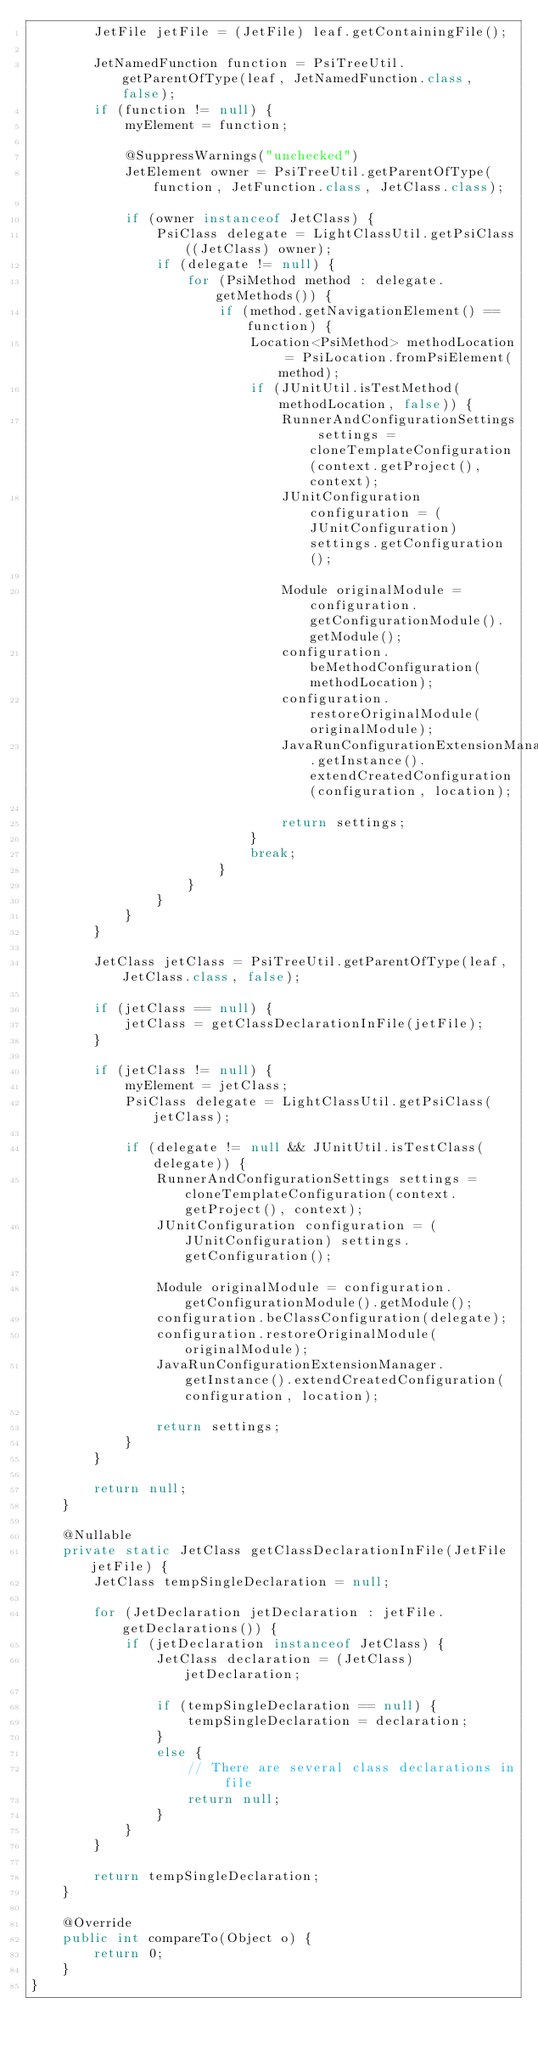<code> <loc_0><loc_0><loc_500><loc_500><_Java_>        JetFile jetFile = (JetFile) leaf.getContainingFile();

        JetNamedFunction function = PsiTreeUtil.getParentOfType(leaf, JetNamedFunction.class, false);
        if (function != null) {
            myElement = function;

            @SuppressWarnings("unchecked")
            JetElement owner = PsiTreeUtil.getParentOfType(function, JetFunction.class, JetClass.class);

            if (owner instanceof JetClass) {
                PsiClass delegate = LightClassUtil.getPsiClass((JetClass) owner);
                if (delegate != null) {
                    for (PsiMethod method : delegate.getMethods()) {
                        if (method.getNavigationElement() == function) {
                            Location<PsiMethod> methodLocation = PsiLocation.fromPsiElement(method);
                            if (JUnitUtil.isTestMethod(methodLocation, false)) {
                                RunnerAndConfigurationSettings settings = cloneTemplateConfiguration(context.getProject(), context);
                                JUnitConfiguration configuration = (JUnitConfiguration) settings.getConfiguration();

                                Module originalModule = configuration.getConfigurationModule().getModule();
                                configuration.beMethodConfiguration(methodLocation);
                                configuration.restoreOriginalModule(originalModule);
                                JavaRunConfigurationExtensionManager.getInstance().extendCreatedConfiguration(configuration, location);

                                return settings;
                            }
                            break;
                        }
                    }
                }
            }
        }

        JetClass jetClass = PsiTreeUtil.getParentOfType(leaf, JetClass.class, false);

        if (jetClass == null) {
            jetClass = getClassDeclarationInFile(jetFile);
        }

        if (jetClass != null) {
            myElement = jetClass;
            PsiClass delegate = LightClassUtil.getPsiClass(jetClass);

            if (delegate != null && JUnitUtil.isTestClass(delegate)) {
                RunnerAndConfigurationSettings settings = cloneTemplateConfiguration(context.getProject(), context);
                JUnitConfiguration configuration = (JUnitConfiguration) settings.getConfiguration();

                Module originalModule = configuration.getConfigurationModule().getModule();
                configuration.beClassConfiguration(delegate);
                configuration.restoreOriginalModule(originalModule);
                JavaRunConfigurationExtensionManager.getInstance().extendCreatedConfiguration(configuration, location);

                return settings;
            }
        }

        return null;
    }

    @Nullable
    private static JetClass getClassDeclarationInFile(JetFile jetFile) {
        JetClass tempSingleDeclaration = null;

        for (JetDeclaration jetDeclaration : jetFile.getDeclarations()) {
            if (jetDeclaration instanceof JetClass) {
                JetClass declaration = (JetClass) jetDeclaration;

                if (tempSingleDeclaration == null) {
                    tempSingleDeclaration = declaration;
                }
                else {
                    // There are several class declarations in file
                    return null;
                }
            }
        }

        return tempSingleDeclaration;
    }

    @Override
    public int compareTo(Object o) {
        return 0;
    }
}
</code> 